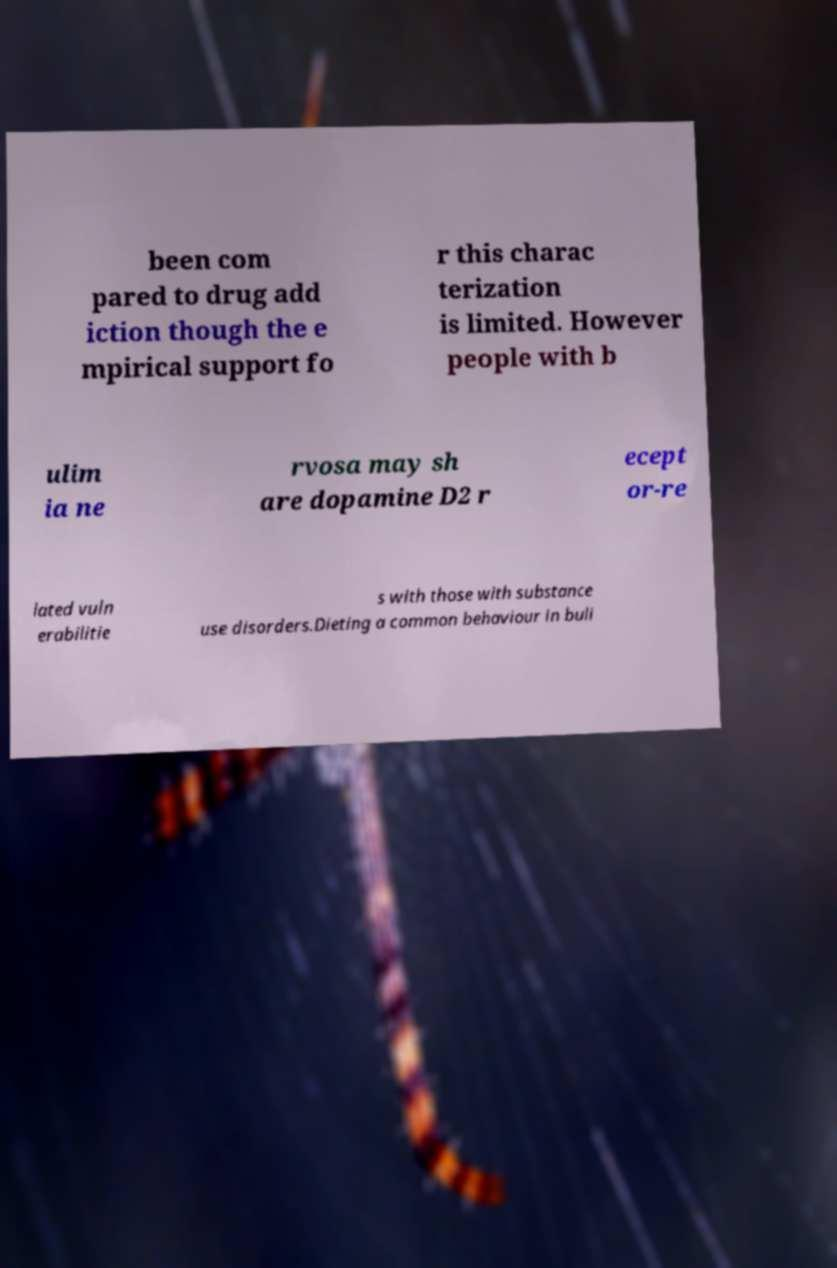There's text embedded in this image that I need extracted. Can you transcribe it verbatim? been com pared to drug add iction though the e mpirical support fo r this charac terization is limited. However people with b ulim ia ne rvosa may sh are dopamine D2 r ecept or-re lated vuln erabilitie s with those with substance use disorders.Dieting a common behaviour in buli 